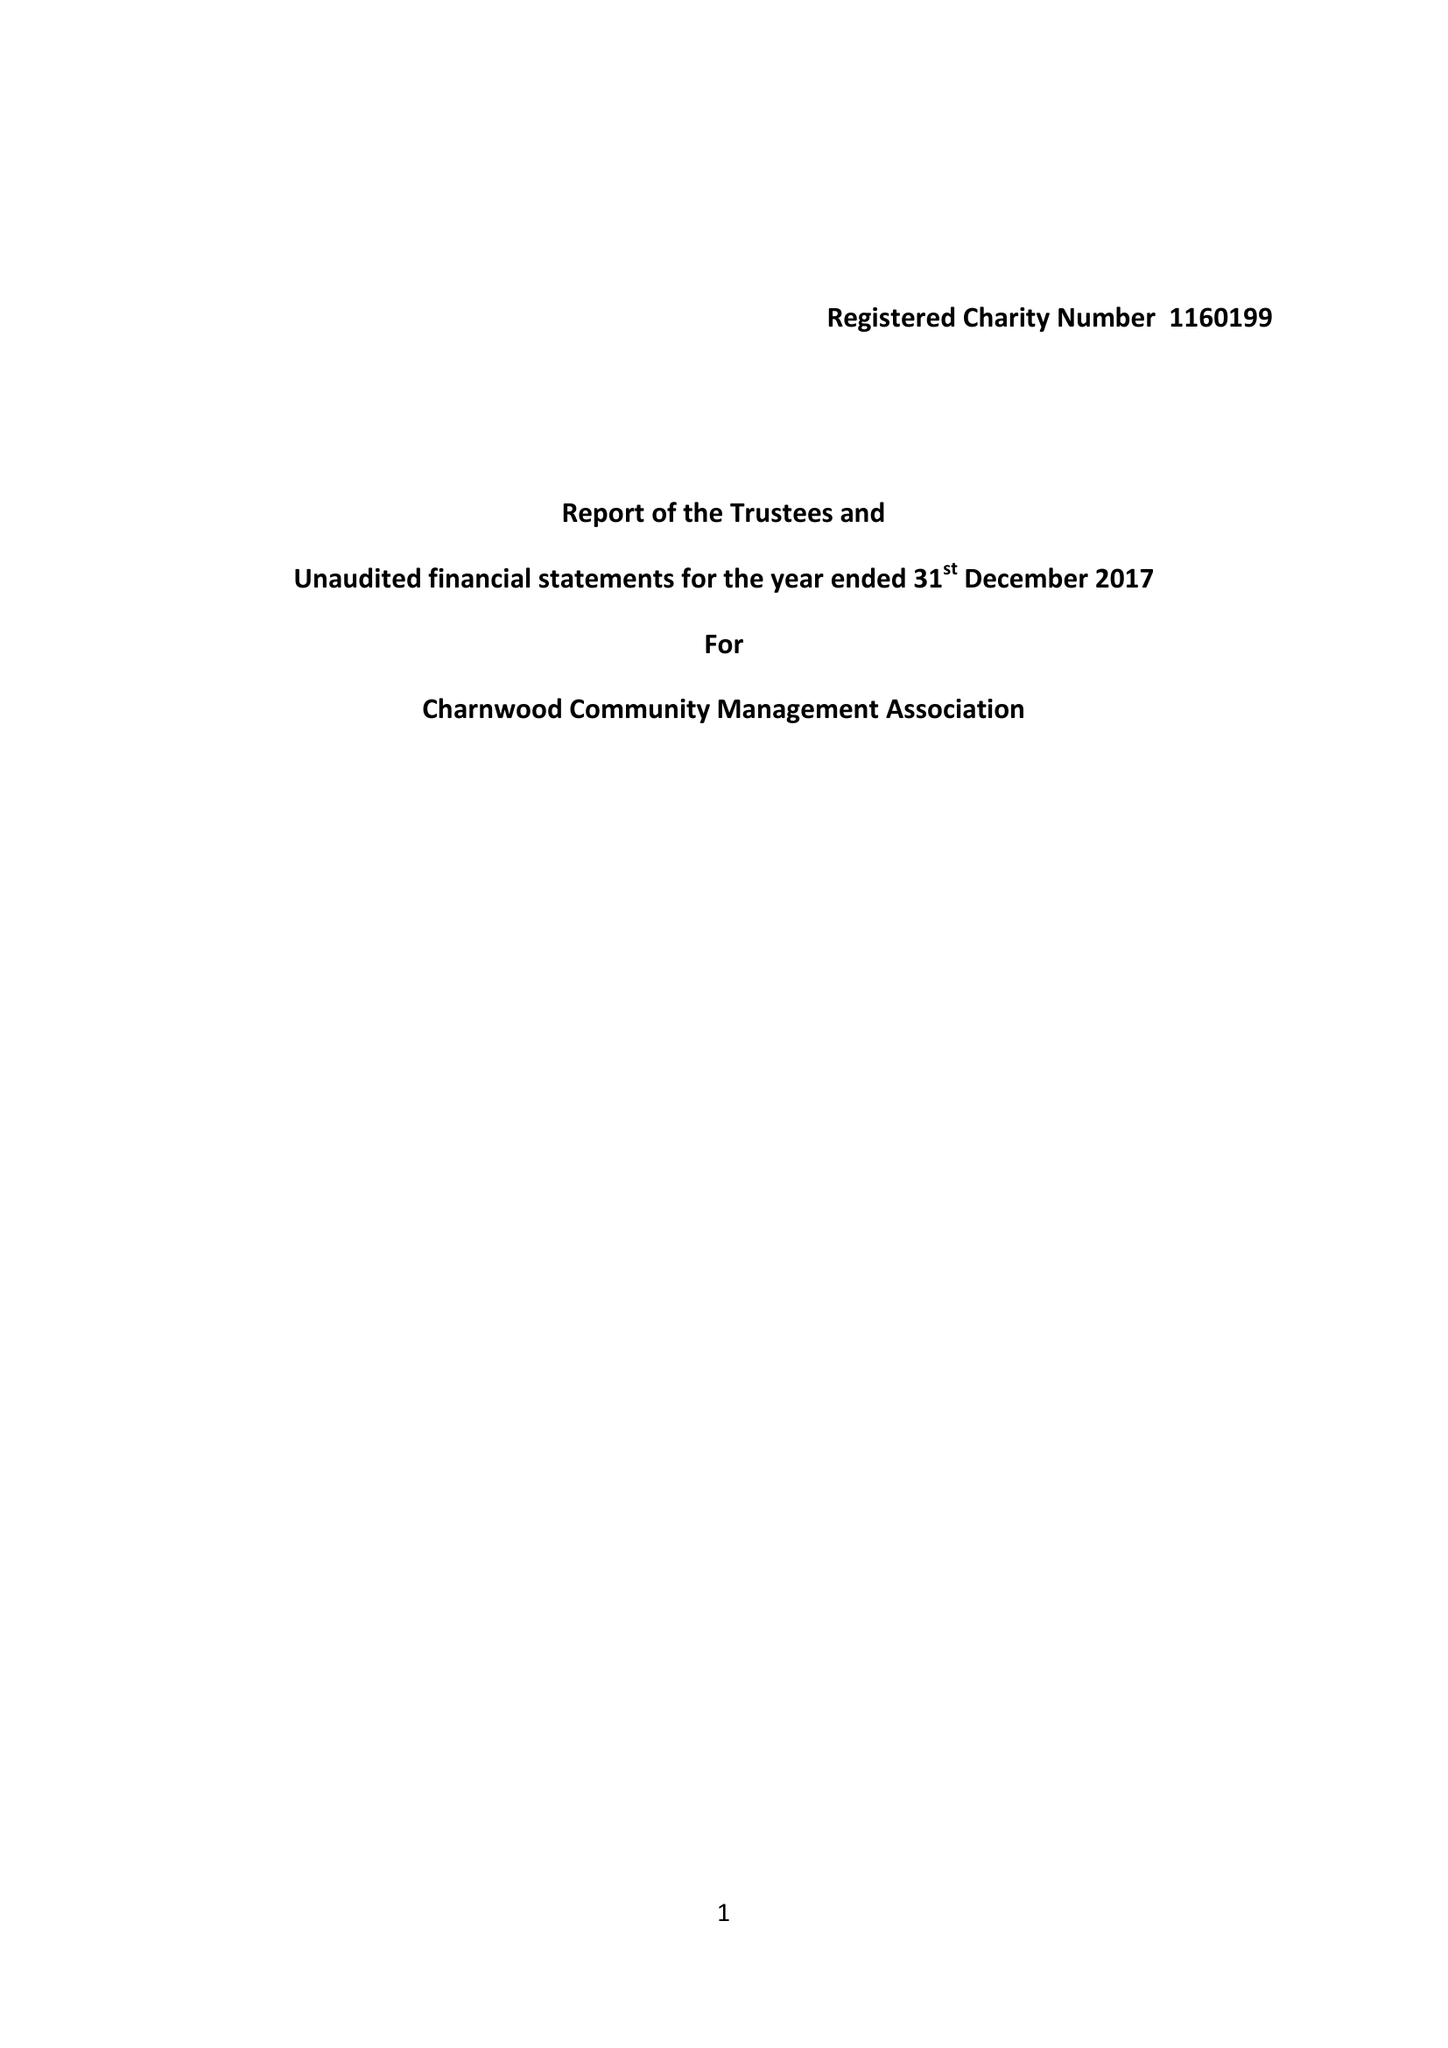What is the value for the income_annually_in_british_pounds?
Answer the question using a single word or phrase. 110.00 